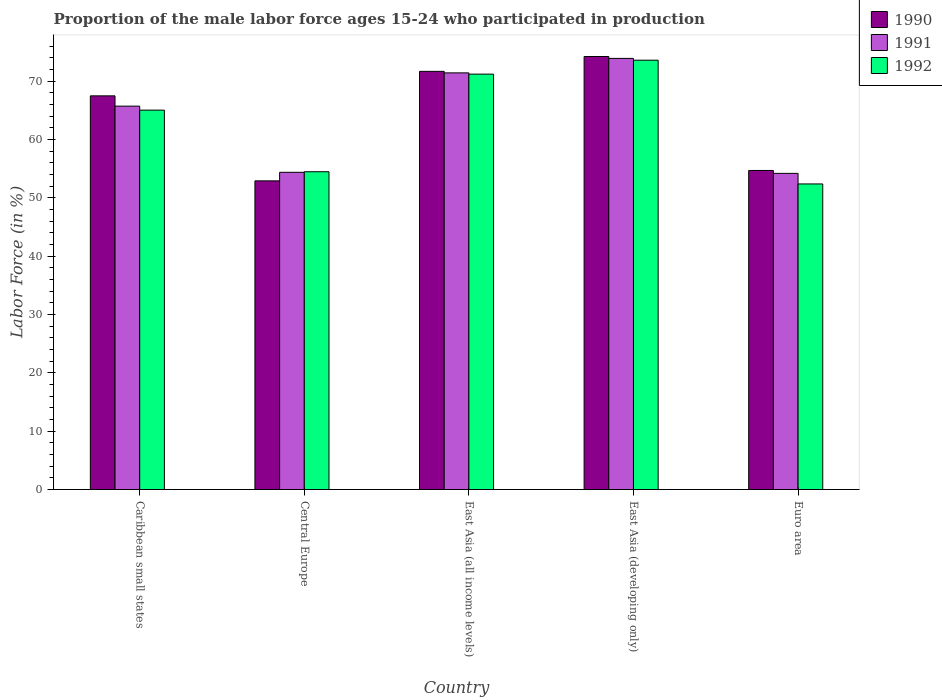How many different coloured bars are there?
Your answer should be compact. 3. How many bars are there on the 1st tick from the left?
Ensure brevity in your answer.  3. What is the label of the 3rd group of bars from the left?
Your answer should be very brief. East Asia (all income levels). What is the proportion of the male labor force who participated in production in 1992 in East Asia (developing only)?
Your answer should be compact. 73.59. Across all countries, what is the maximum proportion of the male labor force who participated in production in 1990?
Give a very brief answer. 74.22. Across all countries, what is the minimum proportion of the male labor force who participated in production in 1992?
Your answer should be very brief. 52.38. In which country was the proportion of the male labor force who participated in production in 1991 maximum?
Provide a succinct answer. East Asia (developing only). In which country was the proportion of the male labor force who participated in production in 1992 minimum?
Your response must be concise. Euro area. What is the total proportion of the male labor force who participated in production in 1991 in the graph?
Offer a very short reply. 319.6. What is the difference between the proportion of the male labor force who participated in production in 1990 in Caribbean small states and that in East Asia (all income levels)?
Provide a succinct answer. -4.2. What is the difference between the proportion of the male labor force who participated in production in 1990 in Central Europe and the proportion of the male labor force who participated in production in 1991 in East Asia (developing only)?
Ensure brevity in your answer.  -20.99. What is the average proportion of the male labor force who participated in production in 1990 per country?
Your response must be concise. 64.2. What is the difference between the proportion of the male labor force who participated in production of/in 1991 and proportion of the male labor force who participated in production of/in 1992 in Caribbean small states?
Your answer should be very brief. 0.68. In how many countries, is the proportion of the male labor force who participated in production in 1990 greater than 64 %?
Offer a very short reply. 3. What is the ratio of the proportion of the male labor force who participated in production in 1990 in Caribbean small states to that in Euro area?
Ensure brevity in your answer.  1.23. Is the proportion of the male labor force who participated in production in 1990 in Central Europe less than that in East Asia (all income levels)?
Offer a terse response. Yes. What is the difference between the highest and the second highest proportion of the male labor force who participated in production in 1991?
Your response must be concise. -8.18. What is the difference between the highest and the lowest proportion of the male labor force who participated in production in 1992?
Keep it short and to the point. 21.21. What does the 1st bar from the left in East Asia (all income levels) represents?
Provide a short and direct response. 1990. What does the 2nd bar from the right in Central Europe represents?
Keep it short and to the point. 1991. Is it the case that in every country, the sum of the proportion of the male labor force who participated in production in 1991 and proportion of the male labor force who participated in production in 1992 is greater than the proportion of the male labor force who participated in production in 1990?
Ensure brevity in your answer.  Yes. Are all the bars in the graph horizontal?
Keep it short and to the point. No. What is the difference between two consecutive major ticks on the Y-axis?
Offer a very short reply. 10. Does the graph contain any zero values?
Keep it short and to the point. No. Does the graph contain grids?
Offer a very short reply. No. Where does the legend appear in the graph?
Provide a succinct answer. Top right. How are the legend labels stacked?
Offer a terse response. Vertical. What is the title of the graph?
Make the answer very short. Proportion of the male labor force ages 15-24 who participated in production. Does "1996" appear as one of the legend labels in the graph?
Offer a very short reply. No. What is the label or title of the X-axis?
Offer a terse response. Country. What is the Labor Force (in %) of 1990 in Caribbean small states?
Provide a short and direct response. 67.48. What is the Labor Force (in %) of 1991 in Caribbean small states?
Give a very brief answer. 65.72. What is the Labor Force (in %) in 1992 in Caribbean small states?
Your response must be concise. 65.03. What is the Labor Force (in %) of 1990 in Central Europe?
Make the answer very short. 52.91. What is the Labor Force (in %) in 1991 in Central Europe?
Offer a very short reply. 54.37. What is the Labor Force (in %) in 1992 in Central Europe?
Ensure brevity in your answer.  54.47. What is the Labor Force (in %) of 1990 in East Asia (all income levels)?
Offer a very short reply. 71.68. What is the Labor Force (in %) in 1991 in East Asia (all income levels)?
Make the answer very short. 71.42. What is the Labor Force (in %) of 1992 in East Asia (all income levels)?
Provide a short and direct response. 71.2. What is the Labor Force (in %) of 1990 in East Asia (developing only)?
Make the answer very short. 74.22. What is the Labor Force (in %) of 1991 in East Asia (developing only)?
Your response must be concise. 73.9. What is the Labor Force (in %) in 1992 in East Asia (developing only)?
Your answer should be compact. 73.59. What is the Labor Force (in %) of 1990 in Euro area?
Your answer should be very brief. 54.69. What is the Labor Force (in %) of 1991 in Euro area?
Provide a short and direct response. 54.19. What is the Labor Force (in %) of 1992 in Euro area?
Offer a terse response. 52.38. Across all countries, what is the maximum Labor Force (in %) in 1990?
Keep it short and to the point. 74.22. Across all countries, what is the maximum Labor Force (in %) of 1991?
Your response must be concise. 73.9. Across all countries, what is the maximum Labor Force (in %) in 1992?
Ensure brevity in your answer.  73.59. Across all countries, what is the minimum Labor Force (in %) in 1990?
Your answer should be compact. 52.91. Across all countries, what is the minimum Labor Force (in %) in 1991?
Offer a very short reply. 54.19. Across all countries, what is the minimum Labor Force (in %) in 1992?
Offer a terse response. 52.38. What is the total Labor Force (in %) of 1990 in the graph?
Offer a very short reply. 320.98. What is the total Labor Force (in %) of 1991 in the graph?
Offer a terse response. 319.6. What is the total Labor Force (in %) of 1992 in the graph?
Provide a succinct answer. 316.67. What is the difference between the Labor Force (in %) in 1990 in Caribbean small states and that in Central Europe?
Offer a terse response. 14.57. What is the difference between the Labor Force (in %) in 1991 in Caribbean small states and that in Central Europe?
Make the answer very short. 11.34. What is the difference between the Labor Force (in %) in 1992 in Caribbean small states and that in Central Europe?
Your answer should be very brief. 10.56. What is the difference between the Labor Force (in %) in 1990 in Caribbean small states and that in East Asia (all income levels)?
Provide a short and direct response. -4.2. What is the difference between the Labor Force (in %) of 1991 in Caribbean small states and that in East Asia (all income levels)?
Provide a succinct answer. -5.7. What is the difference between the Labor Force (in %) of 1992 in Caribbean small states and that in East Asia (all income levels)?
Make the answer very short. -6.17. What is the difference between the Labor Force (in %) in 1990 in Caribbean small states and that in East Asia (developing only)?
Your response must be concise. -6.74. What is the difference between the Labor Force (in %) in 1991 in Caribbean small states and that in East Asia (developing only)?
Keep it short and to the point. -8.18. What is the difference between the Labor Force (in %) in 1992 in Caribbean small states and that in East Asia (developing only)?
Make the answer very short. -8.56. What is the difference between the Labor Force (in %) in 1990 in Caribbean small states and that in Euro area?
Your response must be concise. 12.79. What is the difference between the Labor Force (in %) of 1991 in Caribbean small states and that in Euro area?
Offer a very short reply. 11.52. What is the difference between the Labor Force (in %) of 1992 in Caribbean small states and that in Euro area?
Offer a terse response. 12.65. What is the difference between the Labor Force (in %) of 1990 in Central Europe and that in East Asia (all income levels)?
Ensure brevity in your answer.  -18.77. What is the difference between the Labor Force (in %) of 1991 in Central Europe and that in East Asia (all income levels)?
Make the answer very short. -17.04. What is the difference between the Labor Force (in %) in 1992 in Central Europe and that in East Asia (all income levels)?
Provide a succinct answer. -16.73. What is the difference between the Labor Force (in %) in 1990 in Central Europe and that in East Asia (developing only)?
Ensure brevity in your answer.  -21.31. What is the difference between the Labor Force (in %) in 1991 in Central Europe and that in East Asia (developing only)?
Make the answer very short. -19.52. What is the difference between the Labor Force (in %) in 1992 in Central Europe and that in East Asia (developing only)?
Provide a short and direct response. -19.12. What is the difference between the Labor Force (in %) of 1990 in Central Europe and that in Euro area?
Your answer should be compact. -1.78. What is the difference between the Labor Force (in %) of 1991 in Central Europe and that in Euro area?
Keep it short and to the point. 0.18. What is the difference between the Labor Force (in %) in 1992 in Central Europe and that in Euro area?
Your response must be concise. 2.09. What is the difference between the Labor Force (in %) of 1990 in East Asia (all income levels) and that in East Asia (developing only)?
Give a very brief answer. -2.54. What is the difference between the Labor Force (in %) in 1991 in East Asia (all income levels) and that in East Asia (developing only)?
Provide a short and direct response. -2.48. What is the difference between the Labor Force (in %) in 1992 in East Asia (all income levels) and that in East Asia (developing only)?
Give a very brief answer. -2.39. What is the difference between the Labor Force (in %) of 1990 in East Asia (all income levels) and that in Euro area?
Provide a succinct answer. 16.99. What is the difference between the Labor Force (in %) in 1991 in East Asia (all income levels) and that in Euro area?
Your answer should be compact. 17.22. What is the difference between the Labor Force (in %) in 1992 in East Asia (all income levels) and that in Euro area?
Make the answer very short. 18.82. What is the difference between the Labor Force (in %) in 1990 in East Asia (developing only) and that in Euro area?
Offer a terse response. 19.53. What is the difference between the Labor Force (in %) in 1991 in East Asia (developing only) and that in Euro area?
Ensure brevity in your answer.  19.71. What is the difference between the Labor Force (in %) in 1992 in East Asia (developing only) and that in Euro area?
Make the answer very short. 21.21. What is the difference between the Labor Force (in %) in 1990 in Caribbean small states and the Labor Force (in %) in 1991 in Central Europe?
Offer a terse response. 13.1. What is the difference between the Labor Force (in %) in 1990 in Caribbean small states and the Labor Force (in %) in 1992 in Central Europe?
Keep it short and to the point. 13.01. What is the difference between the Labor Force (in %) in 1991 in Caribbean small states and the Labor Force (in %) in 1992 in Central Europe?
Provide a succinct answer. 11.25. What is the difference between the Labor Force (in %) in 1990 in Caribbean small states and the Labor Force (in %) in 1991 in East Asia (all income levels)?
Your answer should be very brief. -3.94. What is the difference between the Labor Force (in %) in 1990 in Caribbean small states and the Labor Force (in %) in 1992 in East Asia (all income levels)?
Your answer should be very brief. -3.72. What is the difference between the Labor Force (in %) in 1991 in Caribbean small states and the Labor Force (in %) in 1992 in East Asia (all income levels)?
Your response must be concise. -5.49. What is the difference between the Labor Force (in %) in 1990 in Caribbean small states and the Labor Force (in %) in 1991 in East Asia (developing only)?
Provide a succinct answer. -6.42. What is the difference between the Labor Force (in %) in 1990 in Caribbean small states and the Labor Force (in %) in 1992 in East Asia (developing only)?
Provide a short and direct response. -6.11. What is the difference between the Labor Force (in %) of 1991 in Caribbean small states and the Labor Force (in %) of 1992 in East Asia (developing only)?
Keep it short and to the point. -7.87. What is the difference between the Labor Force (in %) of 1990 in Caribbean small states and the Labor Force (in %) of 1991 in Euro area?
Provide a short and direct response. 13.28. What is the difference between the Labor Force (in %) of 1990 in Caribbean small states and the Labor Force (in %) of 1992 in Euro area?
Keep it short and to the point. 15.1. What is the difference between the Labor Force (in %) in 1991 in Caribbean small states and the Labor Force (in %) in 1992 in Euro area?
Ensure brevity in your answer.  13.34. What is the difference between the Labor Force (in %) of 1990 in Central Europe and the Labor Force (in %) of 1991 in East Asia (all income levels)?
Provide a succinct answer. -18.51. What is the difference between the Labor Force (in %) in 1990 in Central Europe and the Labor Force (in %) in 1992 in East Asia (all income levels)?
Provide a short and direct response. -18.29. What is the difference between the Labor Force (in %) in 1991 in Central Europe and the Labor Force (in %) in 1992 in East Asia (all income levels)?
Ensure brevity in your answer.  -16.83. What is the difference between the Labor Force (in %) of 1990 in Central Europe and the Labor Force (in %) of 1991 in East Asia (developing only)?
Provide a short and direct response. -20.99. What is the difference between the Labor Force (in %) of 1990 in Central Europe and the Labor Force (in %) of 1992 in East Asia (developing only)?
Your response must be concise. -20.68. What is the difference between the Labor Force (in %) of 1991 in Central Europe and the Labor Force (in %) of 1992 in East Asia (developing only)?
Your answer should be very brief. -19.22. What is the difference between the Labor Force (in %) in 1990 in Central Europe and the Labor Force (in %) in 1991 in Euro area?
Ensure brevity in your answer.  -1.29. What is the difference between the Labor Force (in %) in 1990 in Central Europe and the Labor Force (in %) in 1992 in Euro area?
Give a very brief answer. 0.53. What is the difference between the Labor Force (in %) of 1991 in Central Europe and the Labor Force (in %) of 1992 in Euro area?
Your answer should be compact. 2. What is the difference between the Labor Force (in %) in 1990 in East Asia (all income levels) and the Labor Force (in %) in 1991 in East Asia (developing only)?
Provide a succinct answer. -2.22. What is the difference between the Labor Force (in %) of 1990 in East Asia (all income levels) and the Labor Force (in %) of 1992 in East Asia (developing only)?
Make the answer very short. -1.91. What is the difference between the Labor Force (in %) in 1991 in East Asia (all income levels) and the Labor Force (in %) in 1992 in East Asia (developing only)?
Your answer should be very brief. -2.17. What is the difference between the Labor Force (in %) in 1990 in East Asia (all income levels) and the Labor Force (in %) in 1991 in Euro area?
Your response must be concise. 17.49. What is the difference between the Labor Force (in %) in 1990 in East Asia (all income levels) and the Labor Force (in %) in 1992 in Euro area?
Keep it short and to the point. 19.3. What is the difference between the Labor Force (in %) in 1991 in East Asia (all income levels) and the Labor Force (in %) in 1992 in Euro area?
Offer a terse response. 19.04. What is the difference between the Labor Force (in %) of 1990 in East Asia (developing only) and the Labor Force (in %) of 1991 in Euro area?
Provide a succinct answer. 20.03. What is the difference between the Labor Force (in %) of 1990 in East Asia (developing only) and the Labor Force (in %) of 1992 in Euro area?
Make the answer very short. 21.84. What is the difference between the Labor Force (in %) in 1991 in East Asia (developing only) and the Labor Force (in %) in 1992 in Euro area?
Offer a very short reply. 21.52. What is the average Labor Force (in %) of 1990 per country?
Make the answer very short. 64.2. What is the average Labor Force (in %) in 1991 per country?
Make the answer very short. 63.92. What is the average Labor Force (in %) of 1992 per country?
Keep it short and to the point. 63.34. What is the difference between the Labor Force (in %) in 1990 and Labor Force (in %) in 1991 in Caribbean small states?
Make the answer very short. 1.76. What is the difference between the Labor Force (in %) of 1990 and Labor Force (in %) of 1992 in Caribbean small states?
Your answer should be very brief. 2.45. What is the difference between the Labor Force (in %) in 1991 and Labor Force (in %) in 1992 in Caribbean small states?
Provide a short and direct response. 0.68. What is the difference between the Labor Force (in %) of 1990 and Labor Force (in %) of 1991 in Central Europe?
Your response must be concise. -1.47. What is the difference between the Labor Force (in %) of 1990 and Labor Force (in %) of 1992 in Central Europe?
Offer a very short reply. -1.56. What is the difference between the Labor Force (in %) of 1991 and Labor Force (in %) of 1992 in Central Europe?
Give a very brief answer. -0.09. What is the difference between the Labor Force (in %) of 1990 and Labor Force (in %) of 1991 in East Asia (all income levels)?
Offer a very short reply. 0.26. What is the difference between the Labor Force (in %) in 1990 and Labor Force (in %) in 1992 in East Asia (all income levels)?
Make the answer very short. 0.48. What is the difference between the Labor Force (in %) in 1991 and Labor Force (in %) in 1992 in East Asia (all income levels)?
Make the answer very short. 0.21. What is the difference between the Labor Force (in %) of 1990 and Labor Force (in %) of 1991 in East Asia (developing only)?
Make the answer very short. 0.32. What is the difference between the Labor Force (in %) of 1990 and Labor Force (in %) of 1992 in East Asia (developing only)?
Keep it short and to the point. 0.63. What is the difference between the Labor Force (in %) of 1991 and Labor Force (in %) of 1992 in East Asia (developing only)?
Provide a short and direct response. 0.31. What is the difference between the Labor Force (in %) in 1990 and Labor Force (in %) in 1991 in Euro area?
Keep it short and to the point. 0.5. What is the difference between the Labor Force (in %) in 1990 and Labor Force (in %) in 1992 in Euro area?
Keep it short and to the point. 2.31. What is the difference between the Labor Force (in %) of 1991 and Labor Force (in %) of 1992 in Euro area?
Ensure brevity in your answer.  1.81. What is the ratio of the Labor Force (in %) of 1990 in Caribbean small states to that in Central Europe?
Give a very brief answer. 1.28. What is the ratio of the Labor Force (in %) in 1991 in Caribbean small states to that in Central Europe?
Keep it short and to the point. 1.21. What is the ratio of the Labor Force (in %) of 1992 in Caribbean small states to that in Central Europe?
Provide a succinct answer. 1.19. What is the ratio of the Labor Force (in %) of 1990 in Caribbean small states to that in East Asia (all income levels)?
Your answer should be compact. 0.94. What is the ratio of the Labor Force (in %) in 1991 in Caribbean small states to that in East Asia (all income levels)?
Your response must be concise. 0.92. What is the ratio of the Labor Force (in %) of 1992 in Caribbean small states to that in East Asia (all income levels)?
Ensure brevity in your answer.  0.91. What is the ratio of the Labor Force (in %) of 1990 in Caribbean small states to that in East Asia (developing only)?
Make the answer very short. 0.91. What is the ratio of the Labor Force (in %) of 1991 in Caribbean small states to that in East Asia (developing only)?
Your answer should be compact. 0.89. What is the ratio of the Labor Force (in %) of 1992 in Caribbean small states to that in East Asia (developing only)?
Your response must be concise. 0.88. What is the ratio of the Labor Force (in %) of 1990 in Caribbean small states to that in Euro area?
Make the answer very short. 1.23. What is the ratio of the Labor Force (in %) in 1991 in Caribbean small states to that in Euro area?
Offer a terse response. 1.21. What is the ratio of the Labor Force (in %) of 1992 in Caribbean small states to that in Euro area?
Offer a terse response. 1.24. What is the ratio of the Labor Force (in %) in 1990 in Central Europe to that in East Asia (all income levels)?
Offer a very short reply. 0.74. What is the ratio of the Labor Force (in %) in 1991 in Central Europe to that in East Asia (all income levels)?
Give a very brief answer. 0.76. What is the ratio of the Labor Force (in %) in 1992 in Central Europe to that in East Asia (all income levels)?
Make the answer very short. 0.77. What is the ratio of the Labor Force (in %) in 1990 in Central Europe to that in East Asia (developing only)?
Provide a succinct answer. 0.71. What is the ratio of the Labor Force (in %) of 1991 in Central Europe to that in East Asia (developing only)?
Ensure brevity in your answer.  0.74. What is the ratio of the Labor Force (in %) of 1992 in Central Europe to that in East Asia (developing only)?
Make the answer very short. 0.74. What is the ratio of the Labor Force (in %) in 1990 in Central Europe to that in Euro area?
Your answer should be very brief. 0.97. What is the ratio of the Labor Force (in %) of 1992 in Central Europe to that in Euro area?
Your answer should be very brief. 1.04. What is the ratio of the Labor Force (in %) in 1990 in East Asia (all income levels) to that in East Asia (developing only)?
Give a very brief answer. 0.97. What is the ratio of the Labor Force (in %) of 1991 in East Asia (all income levels) to that in East Asia (developing only)?
Ensure brevity in your answer.  0.97. What is the ratio of the Labor Force (in %) of 1992 in East Asia (all income levels) to that in East Asia (developing only)?
Your answer should be compact. 0.97. What is the ratio of the Labor Force (in %) in 1990 in East Asia (all income levels) to that in Euro area?
Provide a short and direct response. 1.31. What is the ratio of the Labor Force (in %) of 1991 in East Asia (all income levels) to that in Euro area?
Provide a succinct answer. 1.32. What is the ratio of the Labor Force (in %) in 1992 in East Asia (all income levels) to that in Euro area?
Ensure brevity in your answer.  1.36. What is the ratio of the Labor Force (in %) in 1990 in East Asia (developing only) to that in Euro area?
Offer a very short reply. 1.36. What is the ratio of the Labor Force (in %) of 1991 in East Asia (developing only) to that in Euro area?
Your answer should be very brief. 1.36. What is the ratio of the Labor Force (in %) in 1992 in East Asia (developing only) to that in Euro area?
Your answer should be compact. 1.41. What is the difference between the highest and the second highest Labor Force (in %) of 1990?
Offer a terse response. 2.54. What is the difference between the highest and the second highest Labor Force (in %) of 1991?
Your response must be concise. 2.48. What is the difference between the highest and the second highest Labor Force (in %) in 1992?
Make the answer very short. 2.39. What is the difference between the highest and the lowest Labor Force (in %) of 1990?
Make the answer very short. 21.31. What is the difference between the highest and the lowest Labor Force (in %) of 1991?
Your answer should be very brief. 19.71. What is the difference between the highest and the lowest Labor Force (in %) in 1992?
Keep it short and to the point. 21.21. 